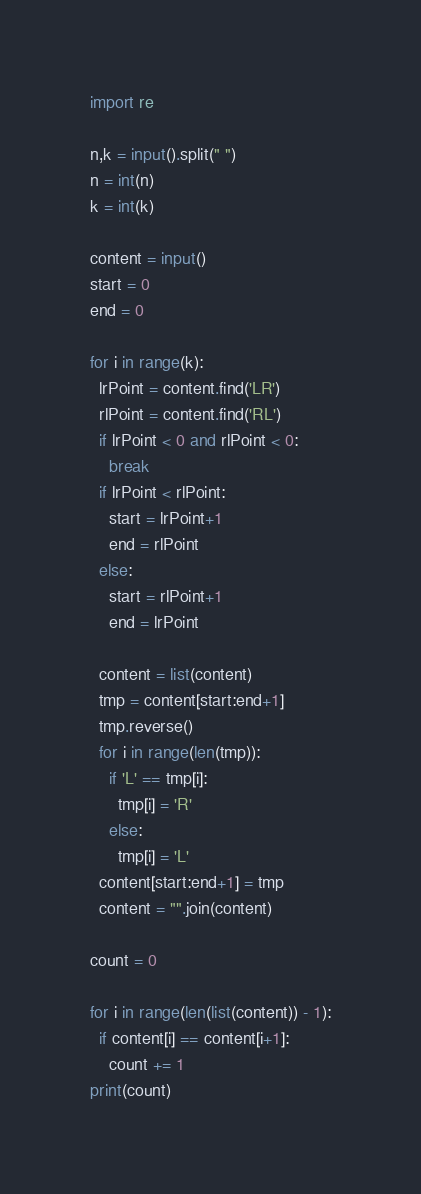Convert code to text. <code><loc_0><loc_0><loc_500><loc_500><_Python_>import re

n,k = input().split(" ")
n = int(n)
k = int(k)

content = input()
start = 0
end = 0

for i in range(k):
  lrPoint = content.find('LR')
  rlPoint = content.find('RL')
  if lrPoint < 0 and rlPoint < 0:
    break
  if lrPoint < rlPoint:
    start = lrPoint+1
    end = rlPoint
  else:
    start = rlPoint+1
    end = lrPoint

  content = list(content)
  tmp = content[start:end+1]
  tmp.reverse()
  for i in range(len(tmp)):
    if 'L' == tmp[i]:
      tmp[i] = 'R'
    else:
      tmp[i] = 'L'
  content[start:end+1] = tmp
  content = "".join(content)
 
count = 0

for i in range(len(list(content)) - 1):
  if content[i] == content[i+1]:
    count += 1
print(count)  </code> 